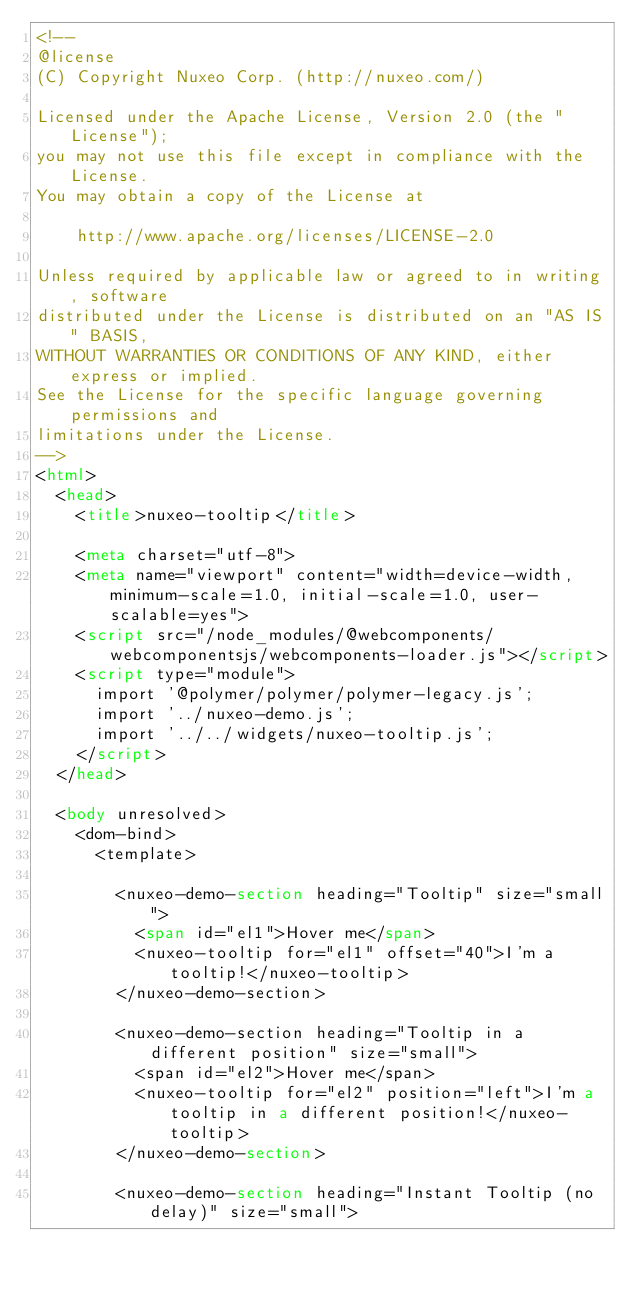<code> <loc_0><loc_0><loc_500><loc_500><_HTML_><!--
@license
(C) Copyright Nuxeo Corp. (http://nuxeo.com/)

Licensed under the Apache License, Version 2.0 (the "License");
you may not use this file except in compliance with the License.
You may obtain a copy of the License at

    http://www.apache.org/licenses/LICENSE-2.0

Unless required by applicable law or agreed to in writing, software
distributed under the License is distributed on an "AS IS" BASIS,
WITHOUT WARRANTIES OR CONDITIONS OF ANY KIND, either express or implied.
See the License for the specific language governing permissions and
limitations under the License.
-->
<html>
  <head>
    <title>nuxeo-tooltip</title>

    <meta charset="utf-8">
    <meta name="viewport" content="width=device-width, minimum-scale=1.0, initial-scale=1.0, user-scalable=yes">
    <script src="/node_modules/@webcomponents/webcomponentsjs/webcomponents-loader.js"></script>
    <script type="module">
      import '@polymer/polymer/polymer-legacy.js';
      import '../nuxeo-demo.js';
      import '../../widgets/nuxeo-tooltip.js';
    </script>
  </head>

  <body unresolved>
    <dom-bind>
      <template>

        <nuxeo-demo-section heading="Tooltip" size="small">
          <span id="el1">Hover me</span>
          <nuxeo-tooltip for="el1" offset="40">I'm a tooltip!</nuxeo-tooltip>
        </nuxeo-demo-section>

        <nuxeo-demo-section heading="Tooltip in a different position" size="small">
          <span id="el2">Hover me</span>
          <nuxeo-tooltip for="el2" position="left">I'm a tooltip in a different position!</nuxeo-tooltip>
        </nuxeo-demo-section>

        <nuxeo-demo-section heading="Instant Tooltip (no delay)" size="small"></code> 